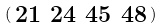<formula> <loc_0><loc_0><loc_500><loc_500>\begin{psmallmatrix} 2 1 & 2 4 & 4 5 & 4 8 \end{psmallmatrix}</formula> 